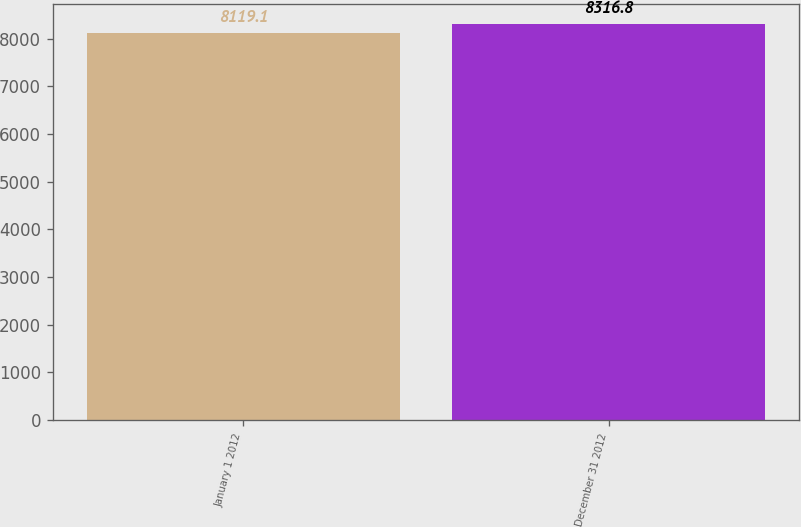<chart> <loc_0><loc_0><loc_500><loc_500><bar_chart><fcel>January 1 2012<fcel>December 31 2012<nl><fcel>8119.1<fcel>8316.8<nl></chart> 